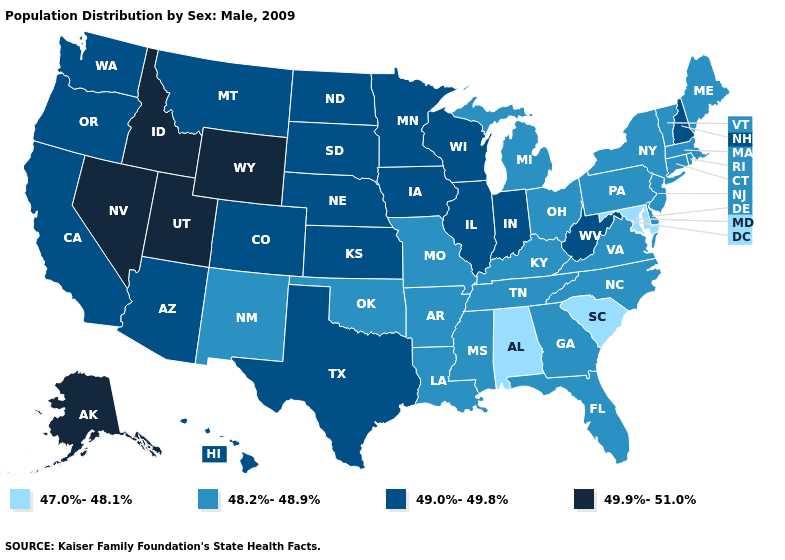What is the highest value in the USA?
Write a very short answer. 49.9%-51.0%. Name the states that have a value in the range 49.0%-49.8%?
Keep it brief. Arizona, California, Colorado, Hawaii, Illinois, Indiana, Iowa, Kansas, Minnesota, Montana, Nebraska, New Hampshire, North Dakota, Oregon, South Dakota, Texas, Washington, West Virginia, Wisconsin. What is the value of New Jersey?
Keep it brief. 48.2%-48.9%. Among the states that border Colorado , does Wyoming have the highest value?
Answer briefly. Yes. Does the first symbol in the legend represent the smallest category?
Give a very brief answer. Yes. Does the first symbol in the legend represent the smallest category?
Write a very short answer. Yes. What is the highest value in the Northeast ?
Short answer required. 49.0%-49.8%. What is the value of Virginia?
Concise answer only. 48.2%-48.9%. Does the map have missing data?
Short answer required. No. Name the states that have a value in the range 47.0%-48.1%?
Be succinct. Alabama, Maryland, South Carolina. Among the states that border Ohio , does Kentucky have the lowest value?
Quick response, please. Yes. Does the map have missing data?
Give a very brief answer. No. What is the value of Louisiana?
Be succinct. 48.2%-48.9%. Is the legend a continuous bar?
Concise answer only. No. Among the states that border South Carolina , which have the highest value?
Keep it brief. Georgia, North Carolina. 